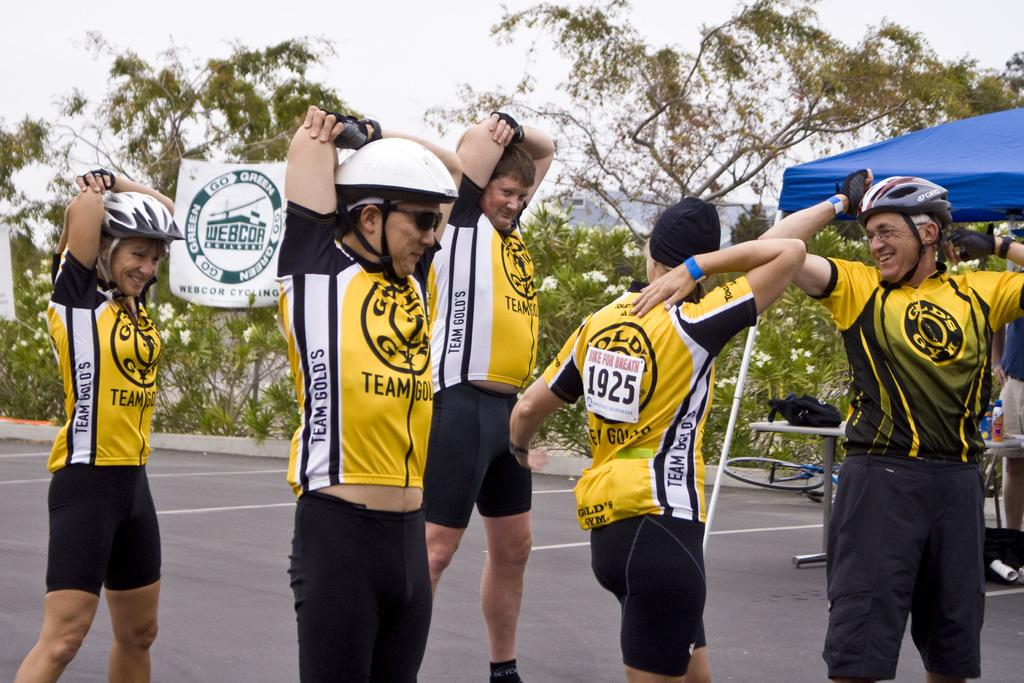<image>
Give a short and clear explanation of the subsequent image. number 1925 runner is stretching with his running mates 